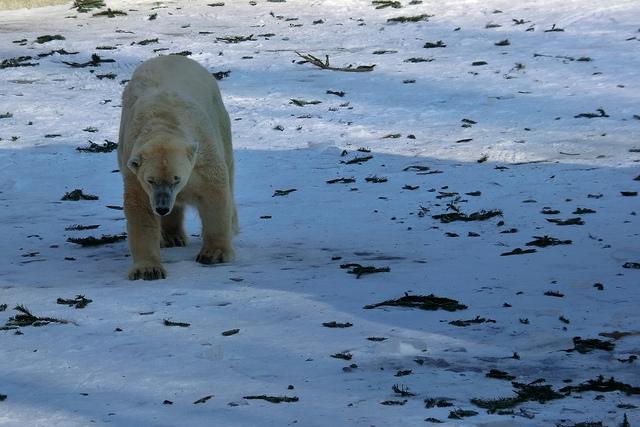Is this animal in captivity?
Concise answer only. No. Is this a real bear?
Quick response, please. Yes. How many animals are shown?
Concise answer only. 1. Is the bear in captivity?
Concise answer only. No. Is the polar bear hungry?
Quick response, please. Yes. 